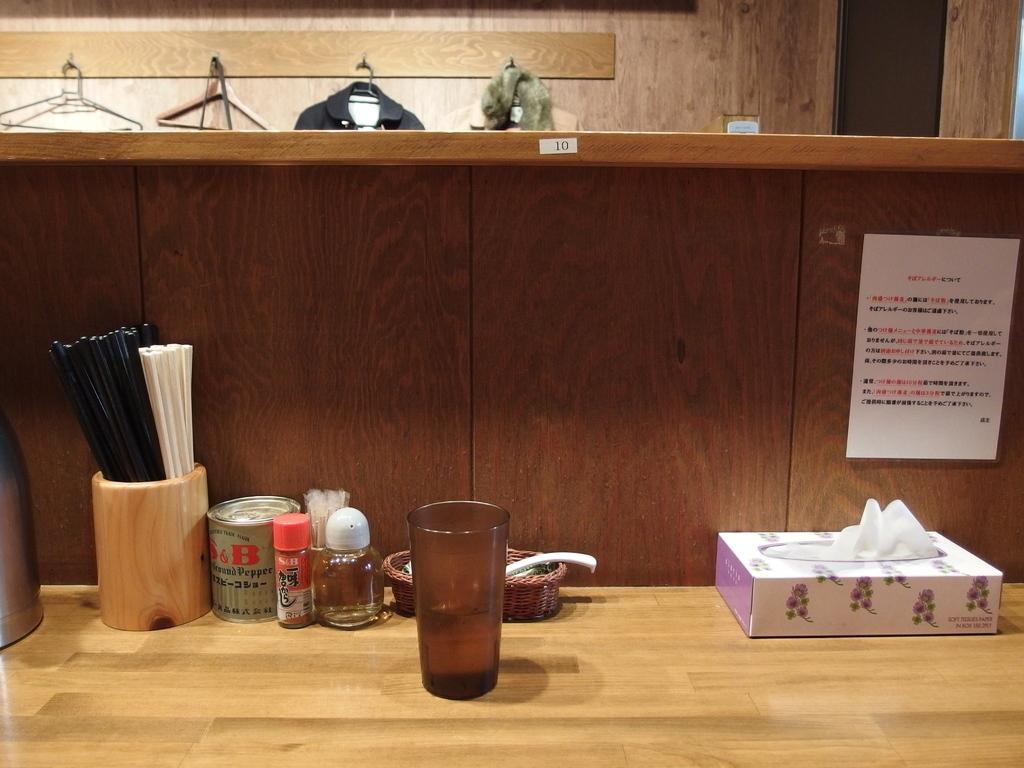What is on the table in the image? There is a glass, a box, and a bottle on the table in the image. What else can be seen in the image besides the objects on the table? There is a poster in the image. What month is depicted on the poster in the image? There is no information about the month or any specific content on the poster, so it cannot be determined from the image. 